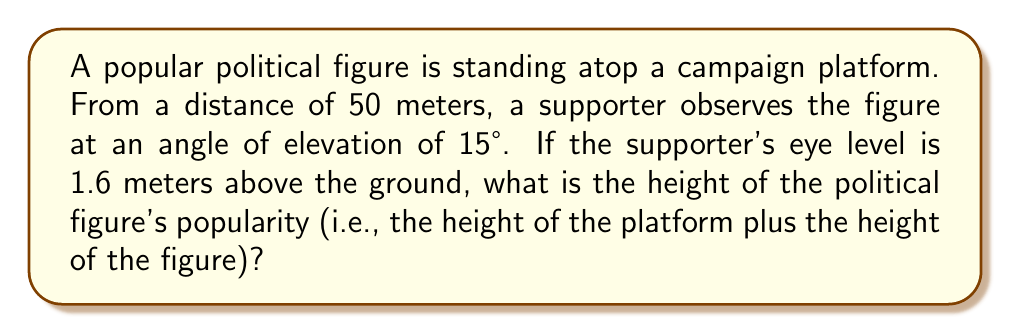Solve this math problem. Let's approach this step-by-step using right-triangle trigonometry:

1) First, we'll draw a right triangle:
   [asy]
   import geometry;
   size(200);
   pair A=(0,0), B=(5,0), C=(5,1.5);
   draw(A--B--C--A);
   draw(rightanglemark(A,B,C,20));
   label("50m",A--B,S);
   label("h",B--C,E);
   label("15°",A,SW);
   label("1.6m",(-0.5,0)--(-0.5,0.16),W);
   [/asy]

2) We know:
   - The adjacent side (ground distance) is 50 meters
   - The angle of elevation is 15°
   - The observer's eye level is 1.6 meters above the ground

3) We need to find the total height (h). We can use the tangent function:

   $$\tan(15°) = \frac{\text{opposite}}{\text{adjacent}} = \frac{h - 1.6}{50}$$

4) Rearranging the equation:

   $$h - 1.6 = 50 \tan(15°)$$

5) Solving for h:

   $$h = 50 \tan(15°) + 1.6$$

6) Now, let's calculate:
   $$\begin{align}
   h &= 50 \times 0.26794919 + 1.6 \\
   &= 13.39745950 + 1.6 \\
   &= 14.99745950 \text{ meters}
   \end{align}$$

7) Rounding to two decimal places for practicality:

   $$h \approx 15.00 \text{ meters}$$

This represents the total height of the political figure's popularity, including the platform and the figure's own height.
Answer: 15.00 meters 